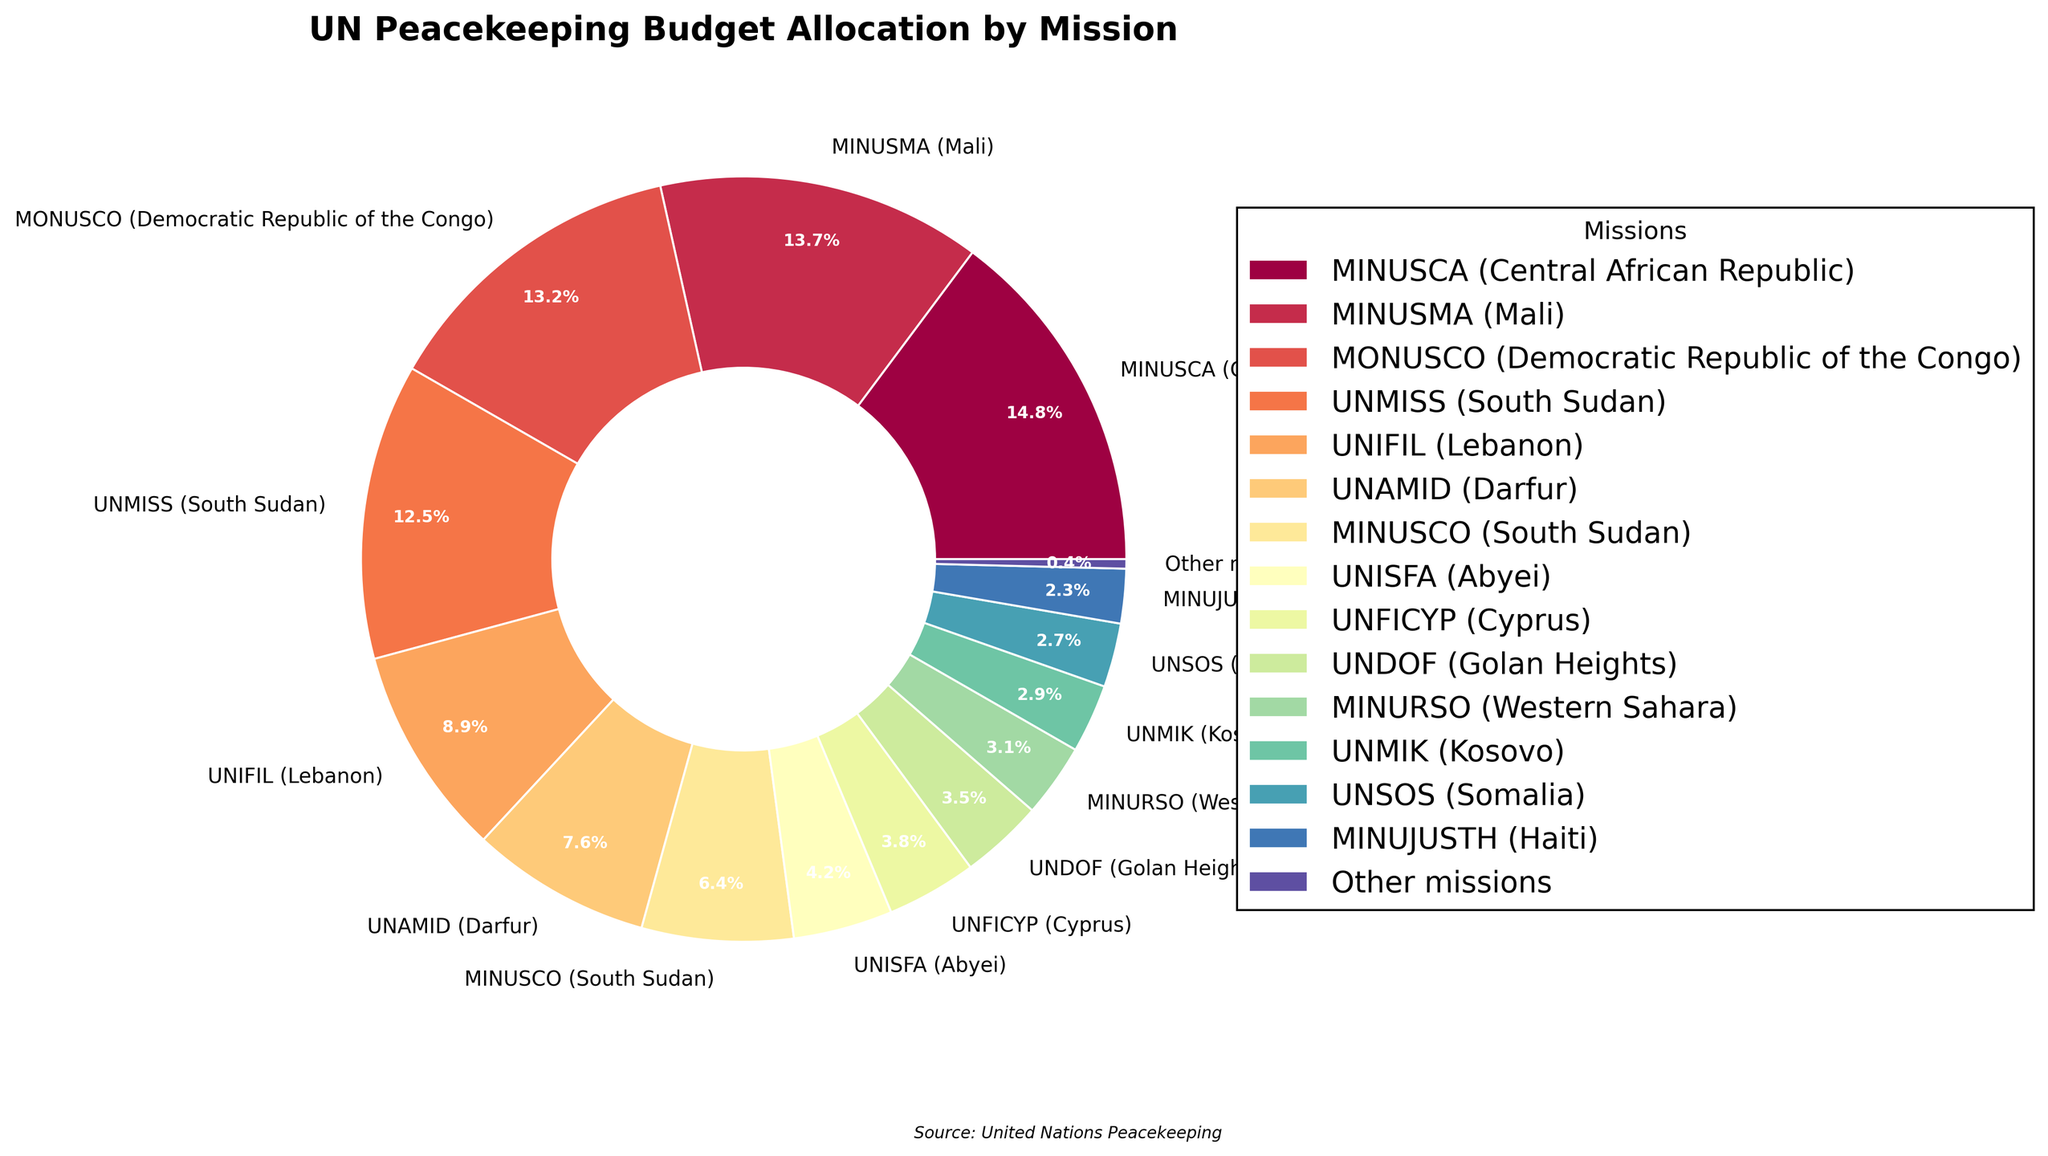What is the mission with the highest budget allocation? By looking at the largest slice in the pie chart with the highest percentage label, it is clear that MINUSCA (Central African Republic) has the highest budget allocation at 14.8%.
Answer: MINUSCA (Central African Republic) Which mission has a lower budget allocation: UNIFIL (Lebanon) or MONUSCO (Democratic Republic of the Congo)? By comparing the percentages seen in the pie chart, UNIFIL (Lebanon) has an 8.9% allocation, whereas MONUSCO (Democratic Republic of the Congo) has a 13.2% allocation. Therefore, UNIFIL has a lower budget allocation.
Answer: UNIFIL (Lebanon) Is the budget allocation for MINUSMA (Mali) greater than that for UNMISS (South Sudan)? Observing the percentages in the pie chart, MINUSMA (Mali) has a budget allocation of 13.7%, while UNMISS (South Sudan) has 12.5%. Therefore, MINUSMA's allocation is greater.
Answer: Yes What is the combined budget allocation for UNAMID (Darfur) and MINUSCO (South Sudan)? To find the combined budget allocation, add the percentages of UNAMID (7.6%) and MINUSCO (6.4%). The total is 7.6 + 6.4 = 14.0%.
Answer: 14.0% Which mission has the smallest budget allocation, and what percentage does it receive? The smallest slice in the pie chart, labeled with the lowest percentage, represents 'Other missions,' which receive 0.4% of the budget allocation.
Answer: Other missions, 0.4% How does the budget allocation for UNFICYP (Cyprus) compare to that for UNISFA (Abyei)? Checking the pie chart, UNFICYP (Cyprus) has an allocation of 3.8%, while UNISFA (Abyei) has 4.2%. Therefore, UNFICYP has a smaller budget allocation.
Answer: UNFICYP has a smaller allocation What is the difference in budget allocation between MINURSO (Western Sahara) and UNMIK (Kosovo)? The difference can be calculated by subtracting the allocation of UNMIK (2.9%) from that of MINURSO (3.1%): 3.1 - 2.9 = 0.2%.
Answer: 0.2% What would be the average budget allocation of the top three missions? First, identify the top three missions: MINUSCA (14.8%), MINUSMA (13.7%), and MONUSCO (13.2%). Then calculate the average: (14.8 + 13.7 + 13.2)/3 = 13.9%.
Answer: 13.9% If the budget for UNMISS (South Sudan) and UNIFIL (Lebanon) combined were reallocated equally between them, what would each mission receive? Calculate the total percentage of both missions: 12.5% (UNMISS) + 8.9% (UNIFIL) = 21.4%. Then divide equally: 21.4 / 2 = 10.7%. Each mission would receive 10.7%.
Answer: 10.7% What is the total budget allocation for missions with more than a 5% allocation? Sum the percentages of missions with more than 5% allocation: MINUSCA (14.8%), MINUSMA (13.7%), MONUSCO (13.2%), UNMISS (12.5%), UNIFIL (8.9%), UNAMID (7.6%), and MINUSCO (6.4%). The total is: 14.8 + 13.7 + 13.2 + 12.5 + 8.9 + 7.6 + 6.4 = 77.1%.
Answer: 77.1% 